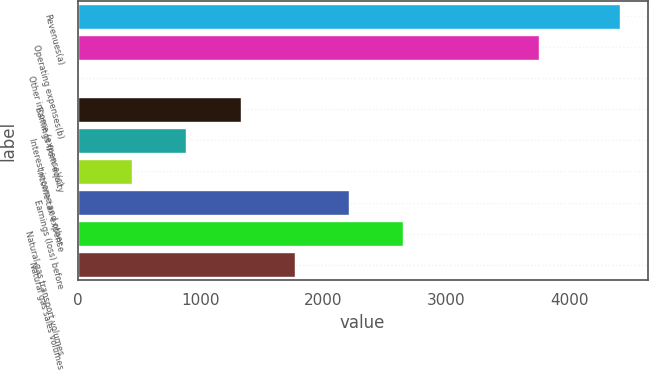Convert chart. <chart><loc_0><loc_0><loc_500><loc_500><bar_chart><fcel>Revenues(a)<fcel>Operating expenses(b)<fcel>Other income (expense)(c)<fcel>Earnings from equity<fcel>Interest income and other<fcel>Income tax expense<fcel>Earnings (loss) before<fcel>Natural gas transport volumes<fcel>Natural gas sales volumes<nl><fcel>4416.5<fcel>3756.8<fcel>0.9<fcel>1325.58<fcel>884.02<fcel>442.46<fcel>2208.7<fcel>2650.26<fcel>1767.14<nl></chart> 